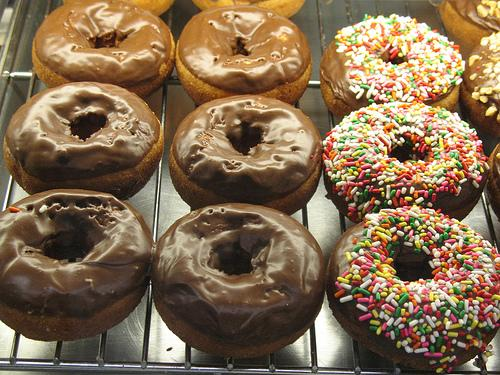Briefly describe the primary object in the image and any additional elements of interest. There's an appetizing donut adorned with chocolate frosting and rainbow sprinkles as its main object, displayed alongside various other donuts with unique toppings on a glossy rack. Explain the main subject of the image and what it conveys. The image's central subject is a delightful donut covered in chocolate icing and rainbow sprinkles, nestled among a variety of other topped donuts on an elegant silver rack. Give a concise overview of the key element in the picture and its setting. The image highlights a tasty donut with chocolate glaze and colorful sprinkles, positioned among an array of donuts with different toppings on a metallic rack. Provide a brief description of the main subject in the image and its surroundings. The image features a delicious donut with chocolate frosting and rainbow sprinkles, surrounded by several other donuts with assorted toppings on a silver rack. Quickly mention the main object in the image along with its key features and setting. The image stars a luscious donut with velvety chocolate icing and multicolored sprinkles, aligned among an assortment of other donuts with various toppings on a polished rack. Summarize the core subject in the picture and provide any noteworthy specifics. The core subject of the image is an inviting donut with sumptuous chocolate frosting and vibrant rainbow sprinkles, presented with other delectable donuts with diverse toppings on a sleek rack. Describe the primary focus of the image and any notable details. The focal point is a scrumptious donut covered in chocolate icing and adorned with rainbow sprinkles, situated among other delectable donuts with varying toppings on a shiny rack. In a few words, describe the primary subject of the image and the context in which it is found. A tempting donut featuring chocolate icing and rainbow sprinkles dominates the image, while assorted topped donuts on a gleaming silver rack provide additional visual interest. Mention the principal object in the picture and its characteristics. The primary object is a donut with chocolate icing and rainbow sprinkles, placed on a silver rack among other donuts with various toppings. What is the main focus of the image and what are some notable accompanying details? The central focus of the image is a mouthwatering donut smeared with rich chocolate icing and rainbow sprinkles, situated alongside a collection of other donuts with assorted toppings on a shiny rack. 